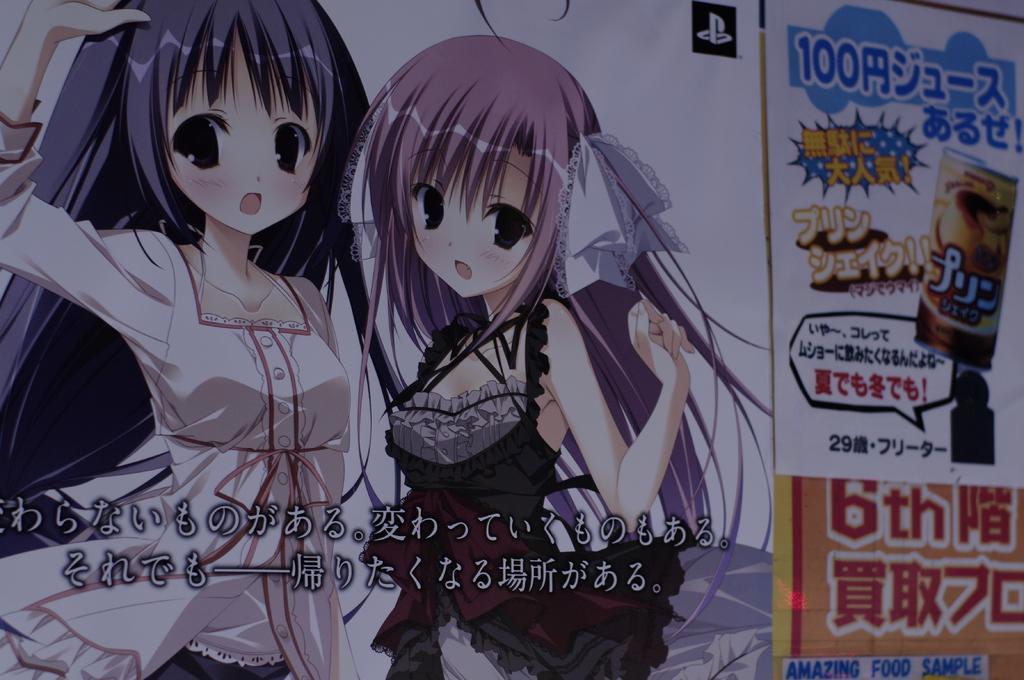Please provide a concise description of this image. In this picture, we can see a poster with some images and text. 